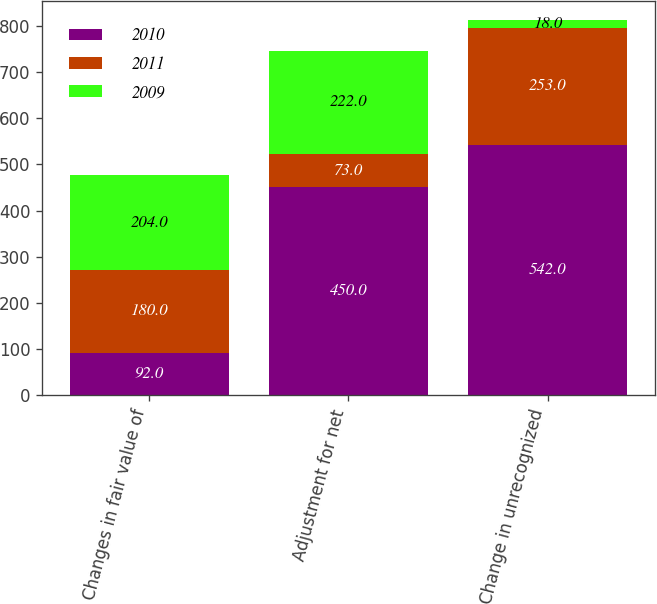Convert chart to OTSL. <chart><loc_0><loc_0><loc_500><loc_500><stacked_bar_chart><ecel><fcel>Changes in fair value of<fcel>Adjustment for net<fcel>Change in unrecognized<nl><fcel>2010<fcel>92<fcel>450<fcel>542<nl><fcel>2011<fcel>180<fcel>73<fcel>253<nl><fcel>2009<fcel>204<fcel>222<fcel>18<nl></chart> 